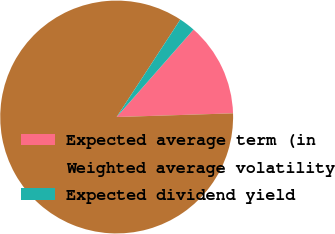Convert chart to OTSL. <chart><loc_0><loc_0><loc_500><loc_500><pie_chart><fcel>Expected average term (in<fcel>Weighted average volatility<fcel>Expected dividend yield<nl><fcel>13.02%<fcel>84.71%<fcel>2.27%<nl></chart> 